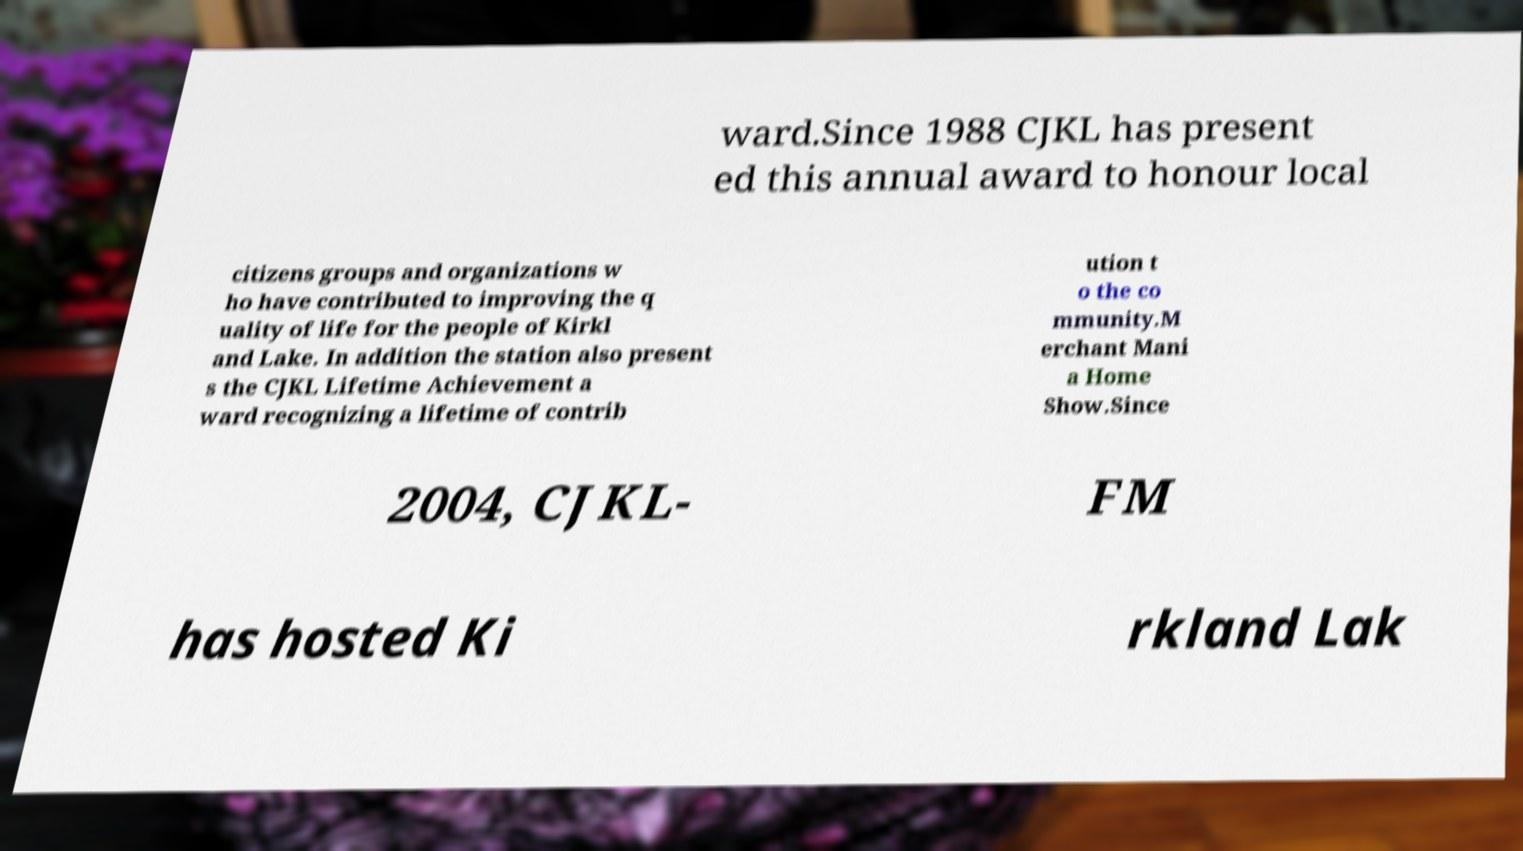There's text embedded in this image that I need extracted. Can you transcribe it verbatim? ward.Since 1988 CJKL has present ed this annual award to honour local citizens groups and organizations w ho have contributed to improving the q uality of life for the people of Kirkl and Lake. In addition the station also present s the CJKL Lifetime Achievement a ward recognizing a lifetime of contrib ution t o the co mmunity.M erchant Mani a Home Show.Since 2004, CJKL- FM has hosted Ki rkland Lak 